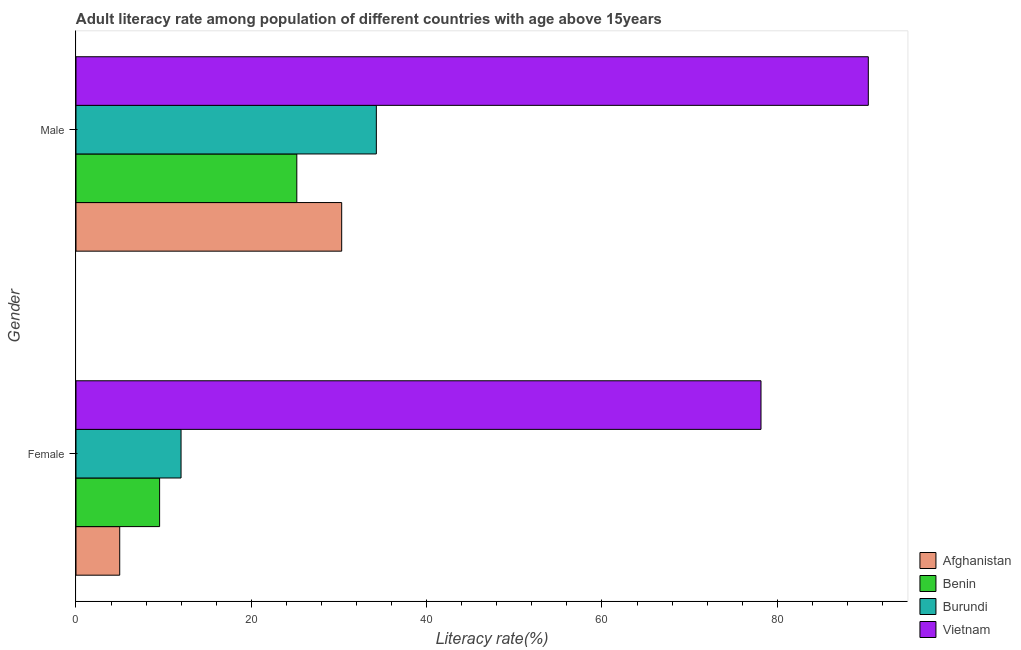How many different coloured bars are there?
Give a very brief answer. 4. How many groups of bars are there?
Make the answer very short. 2. Are the number of bars per tick equal to the number of legend labels?
Give a very brief answer. Yes. Are the number of bars on each tick of the Y-axis equal?
Provide a short and direct response. Yes. How many bars are there on the 2nd tick from the bottom?
Offer a terse response. 4. What is the label of the 1st group of bars from the top?
Your response must be concise. Male. What is the male adult literacy rate in Vietnam?
Provide a short and direct response. 90.38. Across all countries, what is the maximum male adult literacy rate?
Provide a succinct answer. 90.38. Across all countries, what is the minimum female adult literacy rate?
Your answer should be very brief. 4.99. In which country was the male adult literacy rate maximum?
Your answer should be compact. Vietnam. In which country was the female adult literacy rate minimum?
Your response must be concise. Afghanistan. What is the total male adult literacy rate in the graph?
Your response must be concise. 180.14. What is the difference between the female adult literacy rate in Burundi and that in Benin?
Provide a succinct answer. 2.44. What is the difference between the male adult literacy rate in Benin and the female adult literacy rate in Vietnam?
Offer a terse response. -52.95. What is the average male adult literacy rate per country?
Ensure brevity in your answer.  45.04. What is the difference between the male adult literacy rate and female adult literacy rate in Vietnam?
Provide a succinct answer. 12.24. What is the ratio of the male adult literacy rate in Burundi to that in Vietnam?
Provide a short and direct response. 0.38. Is the female adult literacy rate in Afghanistan less than that in Burundi?
Your answer should be compact. Yes. In how many countries, is the male adult literacy rate greater than the average male adult literacy rate taken over all countries?
Give a very brief answer. 1. What does the 3rd bar from the top in Male represents?
Make the answer very short. Benin. What does the 4th bar from the bottom in Female represents?
Offer a very short reply. Vietnam. How many bars are there?
Your answer should be very brief. 8. How many countries are there in the graph?
Your answer should be compact. 4. Does the graph contain any zero values?
Ensure brevity in your answer.  No. Does the graph contain grids?
Make the answer very short. No. How many legend labels are there?
Provide a short and direct response. 4. What is the title of the graph?
Provide a succinct answer. Adult literacy rate among population of different countries with age above 15years. What is the label or title of the X-axis?
Keep it short and to the point. Literacy rate(%). What is the Literacy rate(%) of Afghanistan in Female?
Keep it short and to the point. 4.99. What is the Literacy rate(%) of Benin in Female?
Give a very brief answer. 9.54. What is the Literacy rate(%) in Burundi in Female?
Make the answer very short. 11.98. What is the Literacy rate(%) in Vietnam in Female?
Offer a terse response. 78.14. What is the Literacy rate(%) in Afghanistan in Male?
Provide a succinct answer. 30.31. What is the Literacy rate(%) in Benin in Male?
Provide a short and direct response. 25.19. What is the Literacy rate(%) in Burundi in Male?
Offer a very short reply. 34.26. What is the Literacy rate(%) of Vietnam in Male?
Offer a terse response. 90.38. Across all Gender, what is the maximum Literacy rate(%) in Afghanistan?
Provide a short and direct response. 30.31. Across all Gender, what is the maximum Literacy rate(%) in Benin?
Offer a terse response. 25.19. Across all Gender, what is the maximum Literacy rate(%) in Burundi?
Ensure brevity in your answer.  34.26. Across all Gender, what is the maximum Literacy rate(%) in Vietnam?
Your answer should be compact. 90.38. Across all Gender, what is the minimum Literacy rate(%) of Afghanistan?
Ensure brevity in your answer.  4.99. Across all Gender, what is the minimum Literacy rate(%) of Benin?
Give a very brief answer. 9.54. Across all Gender, what is the minimum Literacy rate(%) in Burundi?
Provide a short and direct response. 11.98. Across all Gender, what is the minimum Literacy rate(%) of Vietnam?
Your answer should be compact. 78.14. What is the total Literacy rate(%) in Afghanistan in the graph?
Make the answer very short. 35.3. What is the total Literacy rate(%) in Benin in the graph?
Provide a short and direct response. 34.73. What is the total Literacy rate(%) in Burundi in the graph?
Provide a short and direct response. 46.25. What is the total Literacy rate(%) in Vietnam in the graph?
Your answer should be compact. 168.52. What is the difference between the Literacy rate(%) of Afghanistan in Female and that in Male?
Your response must be concise. -25.32. What is the difference between the Literacy rate(%) in Benin in Female and that in Male?
Your response must be concise. -15.65. What is the difference between the Literacy rate(%) in Burundi in Female and that in Male?
Your answer should be compact. -22.28. What is the difference between the Literacy rate(%) in Vietnam in Female and that in Male?
Your response must be concise. -12.24. What is the difference between the Literacy rate(%) of Afghanistan in Female and the Literacy rate(%) of Benin in Male?
Keep it short and to the point. -20.2. What is the difference between the Literacy rate(%) in Afghanistan in Female and the Literacy rate(%) in Burundi in Male?
Provide a succinct answer. -29.28. What is the difference between the Literacy rate(%) in Afghanistan in Female and the Literacy rate(%) in Vietnam in Male?
Offer a very short reply. -85.39. What is the difference between the Literacy rate(%) in Benin in Female and the Literacy rate(%) in Burundi in Male?
Your answer should be very brief. -24.72. What is the difference between the Literacy rate(%) of Benin in Female and the Literacy rate(%) of Vietnam in Male?
Your answer should be very brief. -80.84. What is the difference between the Literacy rate(%) in Burundi in Female and the Literacy rate(%) in Vietnam in Male?
Give a very brief answer. -78.4. What is the average Literacy rate(%) in Afghanistan per Gender?
Your answer should be compact. 17.65. What is the average Literacy rate(%) in Benin per Gender?
Provide a succinct answer. 17.36. What is the average Literacy rate(%) of Burundi per Gender?
Provide a short and direct response. 23.12. What is the average Literacy rate(%) in Vietnam per Gender?
Offer a very short reply. 84.26. What is the difference between the Literacy rate(%) in Afghanistan and Literacy rate(%) in Benin in Female?
Keep it short and to the point. -4.55. What is the difference between the Literacy rate(%) in Afghanistan and Literacy rate(%) in Burundi in Female?
Make the answer very short. -7. What is the difference between the Literacy rate(%) of Afghanistan and Literacy rate(%) of Vietnam in Female?
Provide a short and direct response. -73.15. What is the difference between the Literacy rate(%) of Benin and Literacy rate(%) of Burundi in Female?
Provide a succinct answer. -2.44. What is the difference between the Literacy rate(%) in Benin and Literacy rate(%) in Vietnam in Female?
Provide a succinct answer. -68.6. What is the difference between the Literacy rate(%) of Burundi and Literacy rate(%) of Vietnam in Female?
Ensure brevity in your answer.  -66.16. What is the difference between the Literacy rate(%) of Afghanistan and Literacy rate(%) of Benin in Male?
Provide a short and direct response. 5.12. What is the difference between the Literacy rate(%) of Afghanistan and Literacy rate(%) of Burundi in Male?
Provide a short and direct response. -3.96. What is the difference between the Literacy rate(%) in Afghanistan and Literacy rate(%) in Vietnam in Male?
Offer a terse response. -60.07. What is the difference between the Literacy rate(%) of Benin and Literacy rate(%) of Burundi in Male?
Provide a short and direct response. -9.07. What is the difference between the Literacy rate(%) of Benin and Literacy rate(%) of Vietnam in Male?
Make the answer very short. -65.19. What is the difference between the Literacy rate(%) in Burundi and Literacy rate(%) in Vietnam in Male?
Your response must be concise. -56.12. What is the ratio of the Literacy rate(%) in Afghanistan in Female to that in Male?
Your answer should be very brief. 0.16. What is the ratio of the Literacy rate(%) of Benin in Female to that in Male?
Keep it short and to the point. 0.38. What is the ratio of the Literacy rate(%) in Burundi in Female to that in Male?
Your response must be concise. 0.35. What is the ratio of the Literacy rate(%) in Vietnam in Female to that in Male?
Keep it short and to the point. 0.86. What is the difference between the highest and the second highest Literacy rate(%) of Afghanistan?
Offer a terse response. 25.32. What is the difference between the highest and the second highest Literacy rate(%) in Benin?
Your answer should be compact. 15.65. What is the difference between the highest and the second highest Literacy rate(%) in Burundi?
Provide a succinct answer. 22.28. What is the difference between the highest and the second highest Literacy rate(%) of Vietnam?
Offer a terse response. 12.24. What is the difference between the highest and the lowest Literacy rate(%) of Afghanistan?
Make the answer very short. 25.32. What is the difference between the highest and the lowest Literacy rate(%) of Benin?
Your answer should be compact. 15.65. What is the difference between the highest and the lowest Literacy rate(%) in Burundi?
Provide a succinct answer. 22.28. What is the difference between the highest and the lowest Literacy rate(%) in Vietnam?
Make the answer very short. 12.24. 